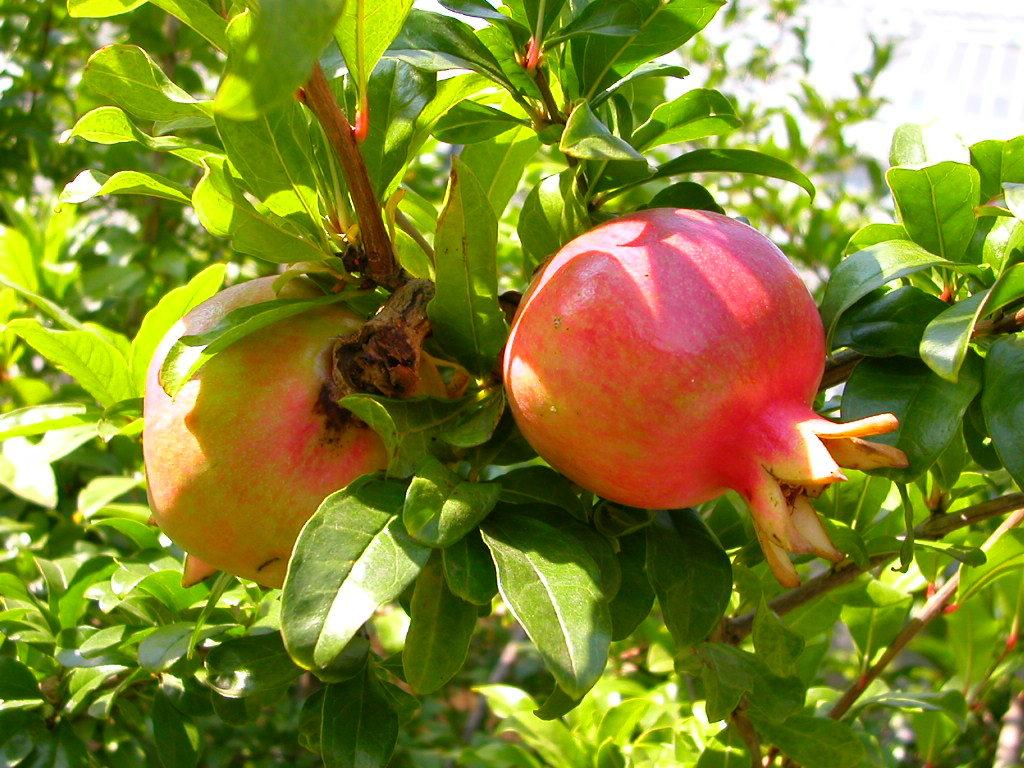How many pomegranates are on the stem in the image? There are two pomegranates on a stem in the image. What can be seen in the background of the image? There are leaves in the background of the image. What type of quilt is being used as bait in the image? There is no quilt or bait present in the image; it features two pomegranates on a stem with leaves in the background. 